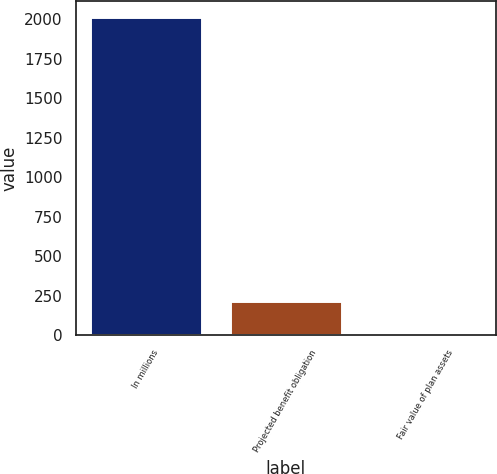Convert chart to OTSL. <chart><loc_0><loc_0><loc_500><loc_500><bar_chart><fcel>In millions<fcel>Projected benefit obligation<fcel>Fair value of plan assets<nl><fcel>2015<fcel>216.44<fcel>16.6<nl></chart> 